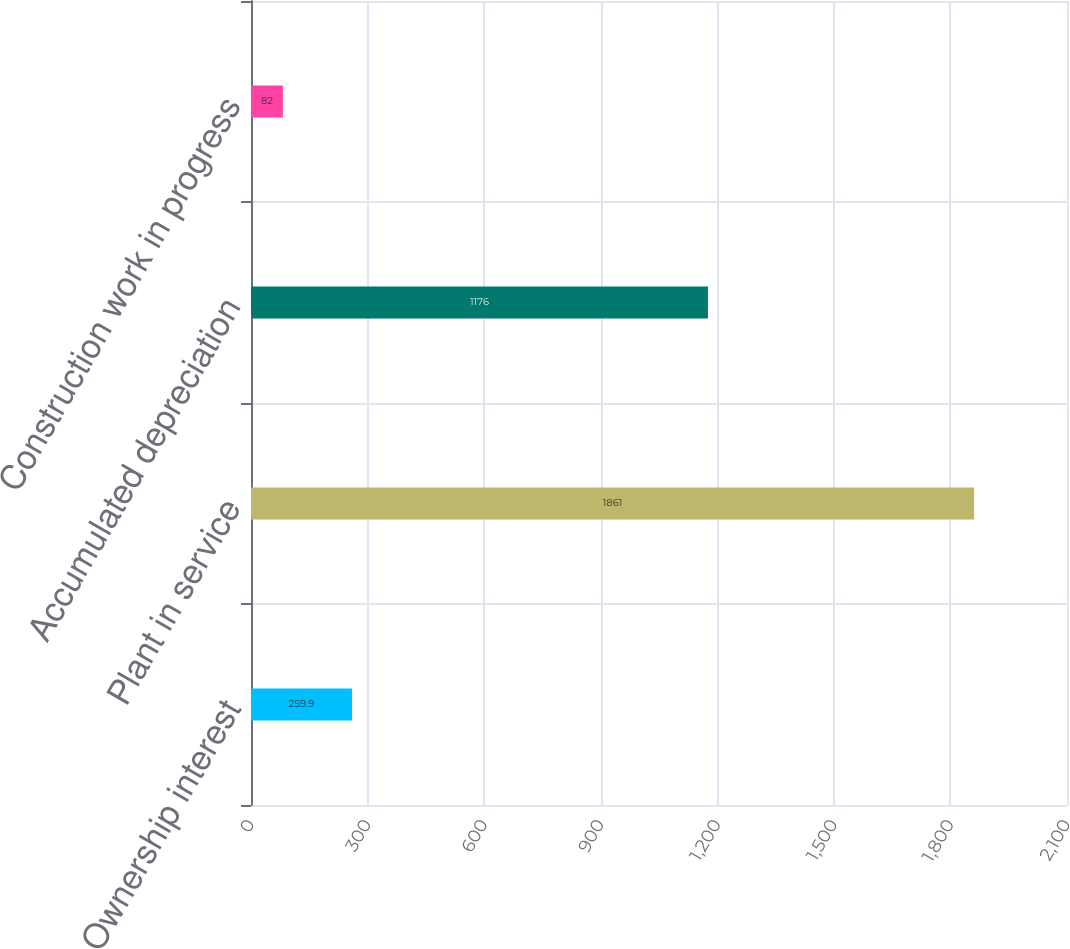<chart> <loc_0><loc_0><loc_500><loc_500><bar_chart><fcel>Ownership interest<fcel>Plant in service<fcel>Accumulated depreciation<fcel>Construction work in progress<nl><fcel>259.9<fcel>1861<fcel>1176<fcel>82<nl></chart> 